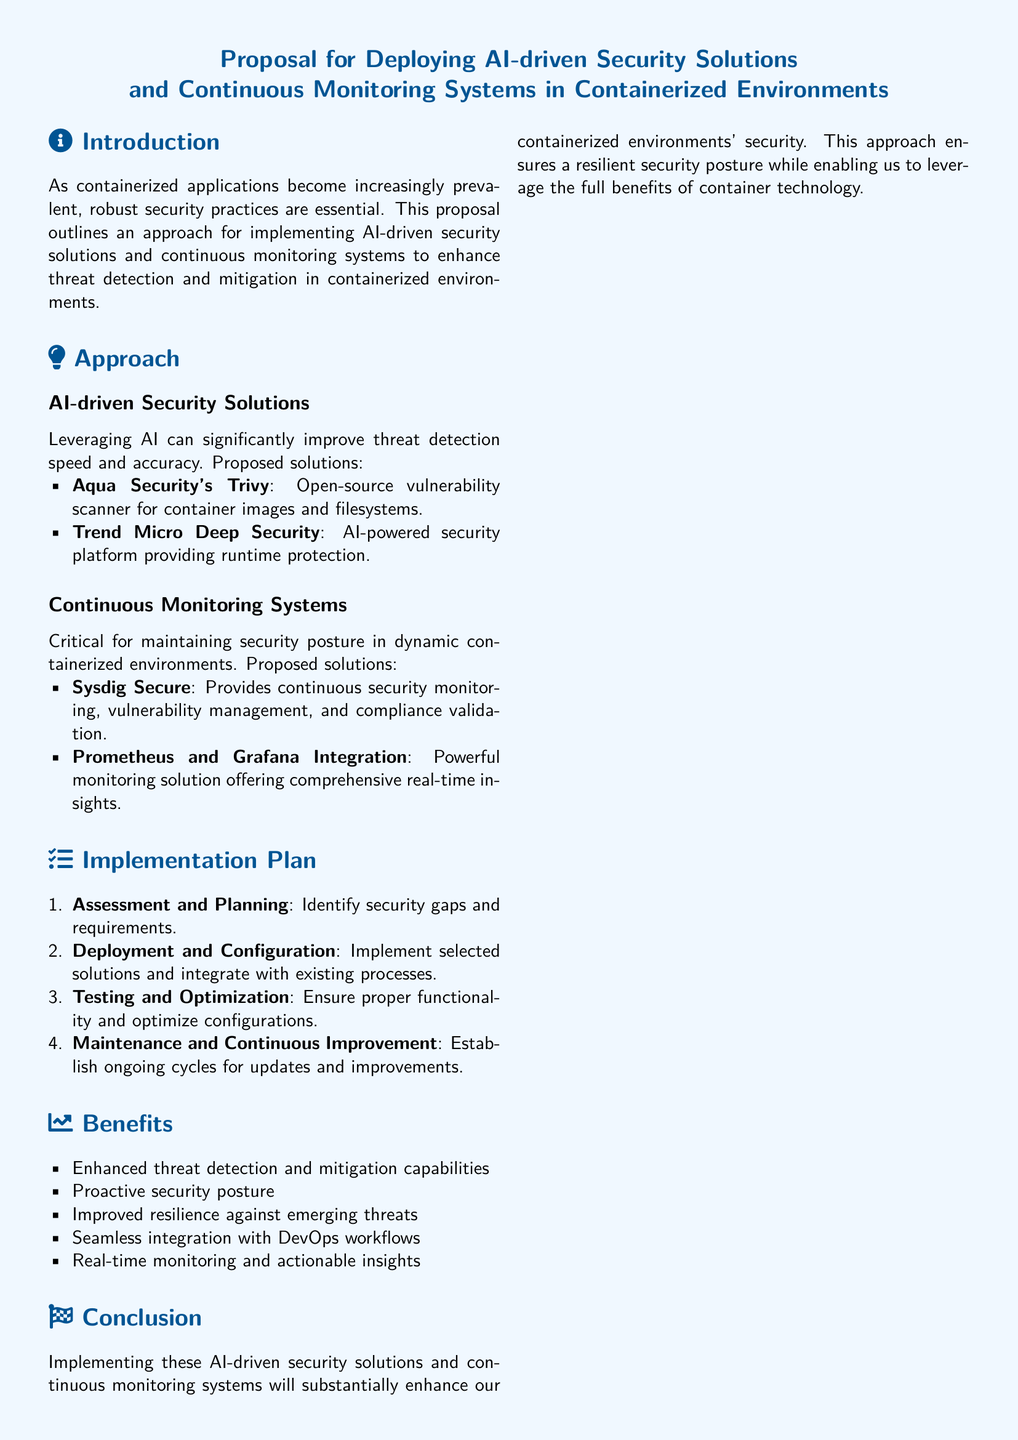what is the main focus of the proposal? The proposal focuses on implementing AI-driven security solutions and continuous monitoring systems to enhance threat detection and mitigation in containerized environments.
Answer: AI-driven security solutions and continuous monitoring systems which vulnerability scanner is mentioned in the proposal? The proposal mentions Aqua Security's Trivy as an open-source vulnerability scanner for container images and filesystems.
Answer: Aqua Security's Trivy what monitoring solution is integrated with Prometheus? The proposal states that Grafana is integrated with Prometheus to provide a powerful monitoring solution offering real-time insights.
Answer: Grafana how many steps are in the implementation plan? The implementation plan consists of four steps outlined in the document.
Answer: Four what benefit is associated with improved resilience? The proposal lists improved resilience against emerging threats as one of the benefits of implementing the solutions.
Answer: Improved resilience against emerging threats what action is suggested as the first of the next steps? The first action suggested in the next steps is to review and approve the proposal.
Answer: Review and approve proposal which AI-powered security platform is mentioned? The proposal mentions Trend Micro Deep Security as an AI-powered security platform providing runtime protection.
Answer: Trend Micro Deep Security what is the purpose of continuous monitoring systems? Continuous monitoring systems are critical for maintaining security posture in dynamic containerized environments.
Answer: Maintaining security posture 